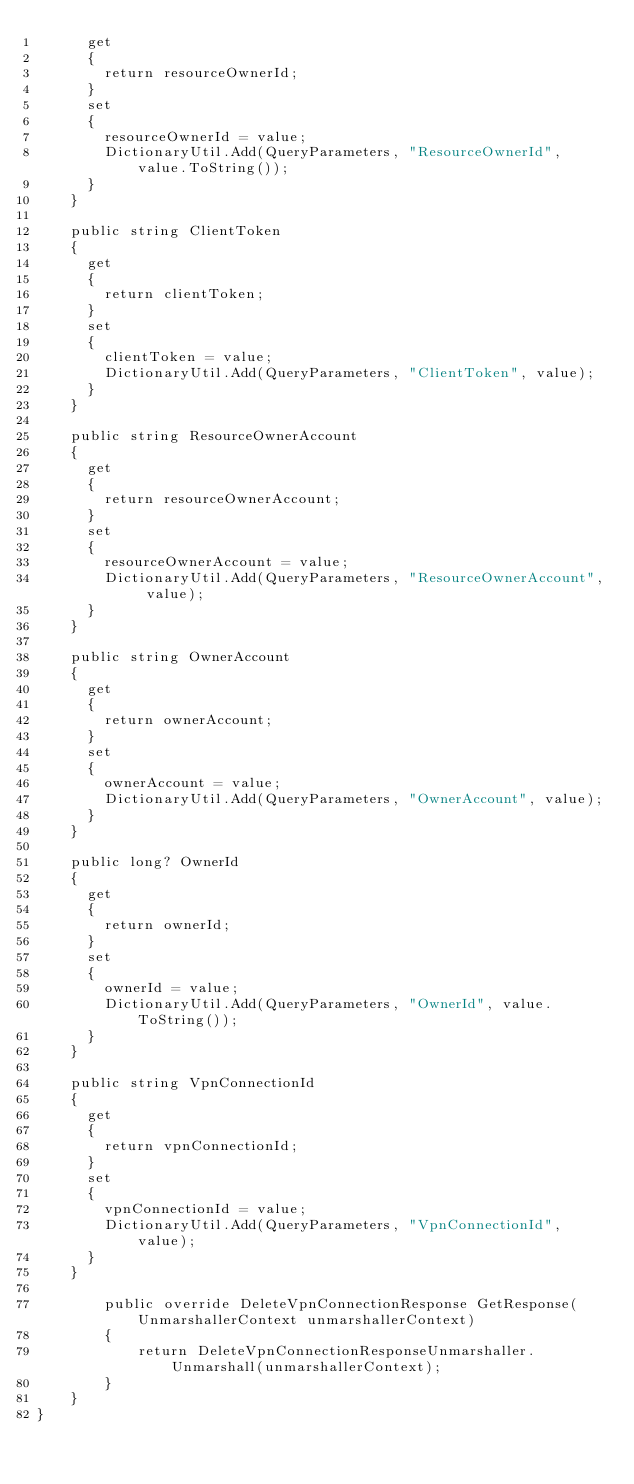Convert code to text. <code><loc_0><loc_0><loc_500><loc_500><_C#_>			get
			{
				return resourceOwnerId;
			}
			set	
			{
				resourceOwnerId = value;
				DictionaryUtil.Add(QueryParameters, "ResourceOwnerId", value.ToString());
			}
		}

		public string ClientToken
		{
			get
			{
				return clientToken;
			}
			set	
			{
				clientToken = value;
				DictionaryUtil.Add(QueryParameters, "ClientToken", value);
			}
		}

		public string ResourceOwnerAccount
		{
			get
			{
				return resourceOwnerAccount;
			}
			set	
			{
				resourceOwnerAccount = value;
				DictionaryUtil.Add(QueryParameters, "ResourceOwnerAccount", value);
			}
		}

		public string OwnerAccount
		{
			get
			{
				return ownerAccount;
			}
			set	
			{
				ownerAccount = value;
				DictionaryUtil.Add(QueryParameters, "OwnerAccount", value);
			}
		}

		public long? OwnerId
		{
			get
			{
				return ownerId;
			}
			set	
			{
				ownerId = value;
				DictionaryUtil.Add(QueryParameters, "OwnerId", value.ToString());
			}
		}

		public string VpnConnectionId
		{
			get
			{
				return vpnConnectionId;
			}
			set	
			{
				vpnConnectionId = value;
				DictionaryUtil.Add(QueryParameters, "VpnConnectionId", value);
			}
		}

        public override DeleteVpnConnectionResponse GetResponse(UnmarshallerContext unmarshallerContext)
        {
            return DeleteVpnConnectionResponseUnmarshaller.Unmarshall(unmarshallerContext);
        }
    }
}
</code> 